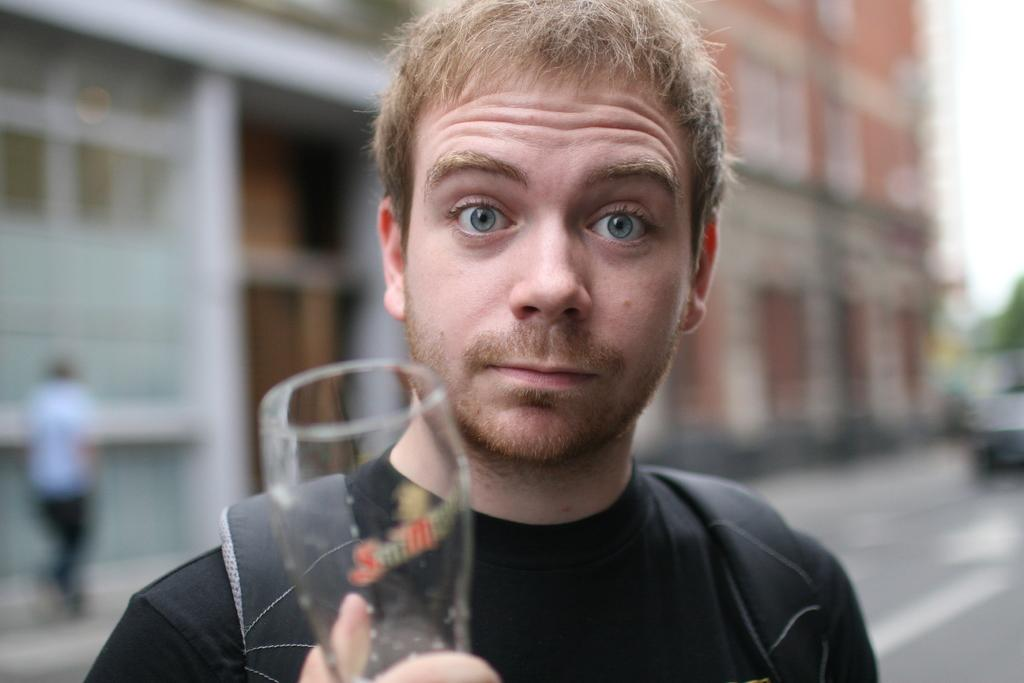What is the person in the image doing? The person is holding a glass and watching something. What is the person holding in the image? The person is holding a glass. What can be seen in the background of the image? There is a wall, a human, and a road in the background of the image. How is the background of the image depicted? The background has a blurred view. What type of stitch is the person using to sew in the image? There is no indication of sewing or stitching in the image; the person is holding a glass and watching something. 